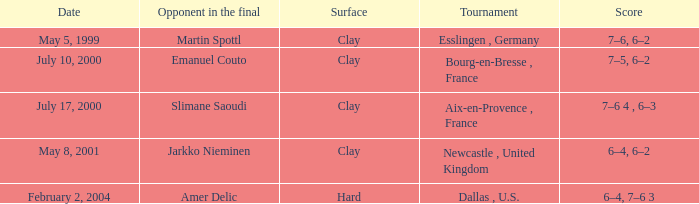What is the Opponent in the final of the game on february 2, 2004? Amer Delic. 